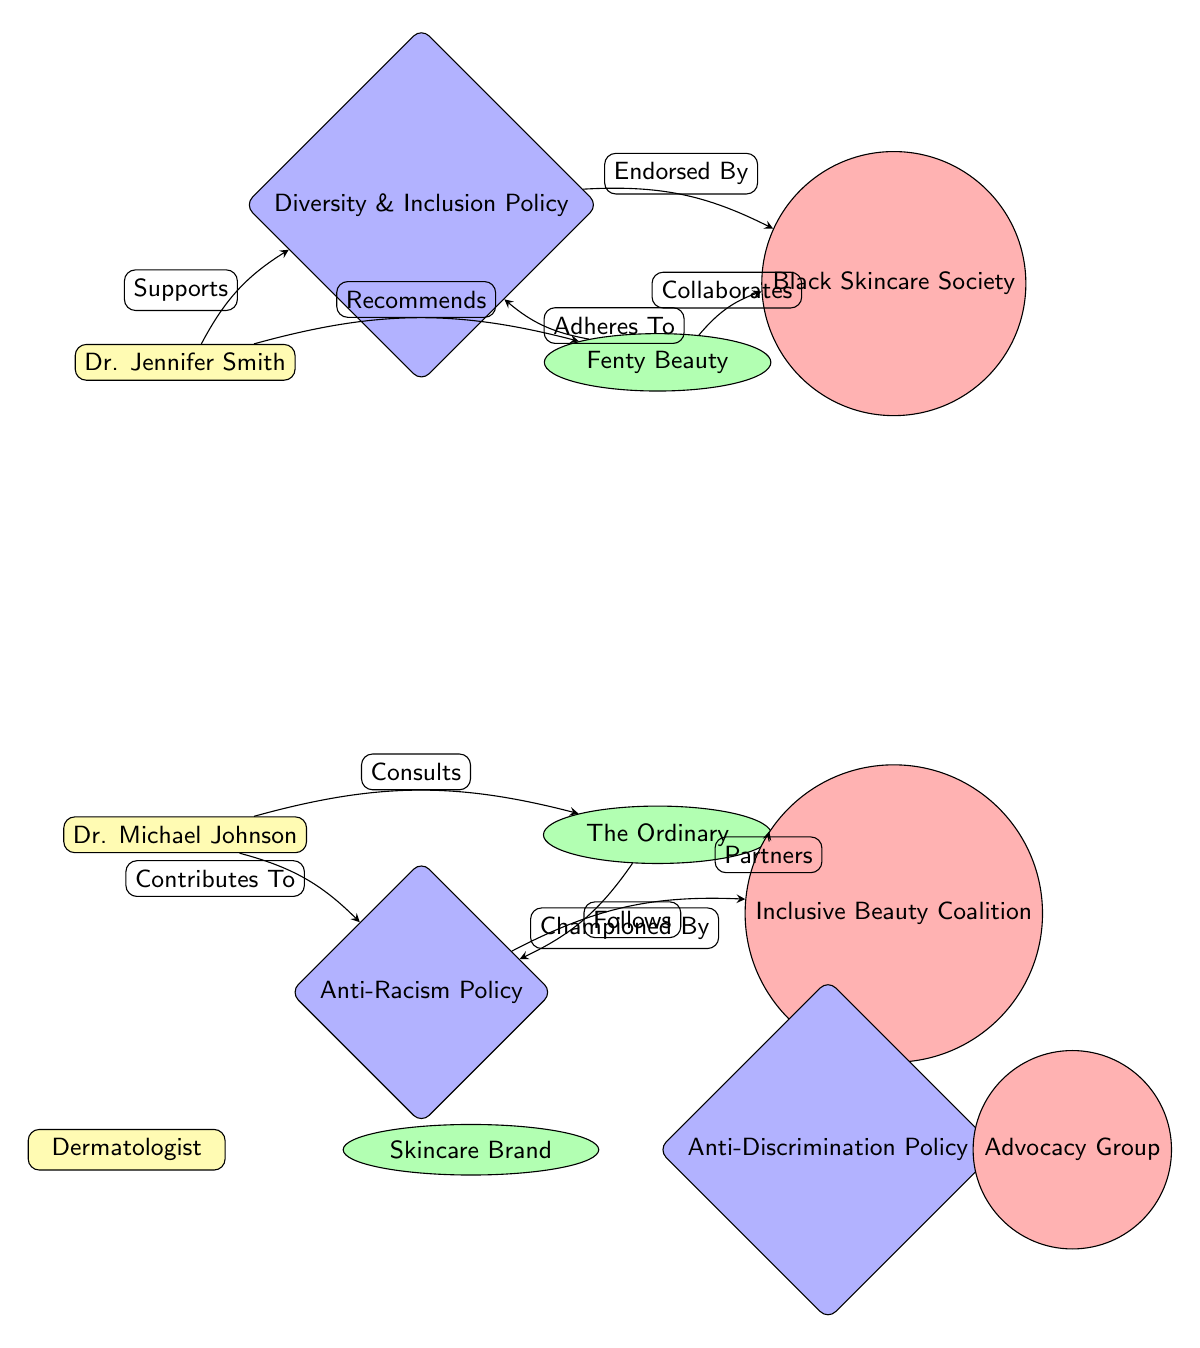What are the two dermatologists in the diagram? The diagram lists two dermatologists labeled as "Dr. Jennifer Smith" and "Dr. Michael Johnson," which can be directly identified from the nodes corresponding to the dermatologist type.
Answer: Dr. Jennifer Smith, Dr. Michael Johnson How many skincare brands are represented in the diagram? By counting the nodes of the skincare brand type, we identify "Fenty Beauty" and "The Ordinary," leading to a total of two skincare brands in the diagram.
Answer: 2 Which policy does Dr. Michael Johnson contribute to? The edge labeled "Contributes To" from "Dr. Michael Johnson" leads to "Anti-Racism Policy," indicating that this is the specific policy he is associated with.
Answer: Anti-Racism Policy What is the relationship between Fenty Beauty and the Diversity & Inclusion Policy? The edge labeled "Adheres To" points from "Fenty Beauty" to "Diversity & Inclusion Policy," depicting that this skincare brand complies with or is aligned with this particular policy.
Answer: Adheres To Which advocacy group collaborates with Fenty Beauty? The connection labeled "Collaborates" between "Fenty Beauty" and "Black Skincare Society" shows that this advocacy group works together with the skincare brand.
Answer: Black Skincare Society Which policy is championed by the Inclusive Beauty Coalition? An edge labeled "Championed By" connects "Anti-Racism Policy" to "Inclusive Beauty Coalition," indicating that the coalition actively promotes or supports this policy.
Answer: Anti-Racism Policy How many edges are there in the diagram? By counting all the connections (or edges) in the diagram, we find there are 10 edges, representing the relationships between nodes.
Answer: 10 What type of connection does Dr. Jennifer Smith have with Fenty Beauty? There is an edge labeled "Recommends" that links "Dr. Jennifer Smith" to "Fenty Beauty," signifying that she endorses this specific skincare brand.
Answer: Recommends What advocacy group is endorsed by the Diversity & Inclusion Policy? The label "Endorsed By" connects "Diversity & Inclusion Policy" to "Black Skincare Society," showing that this policy is supported by the advocacy group.
Answer: Black Skincare Society 